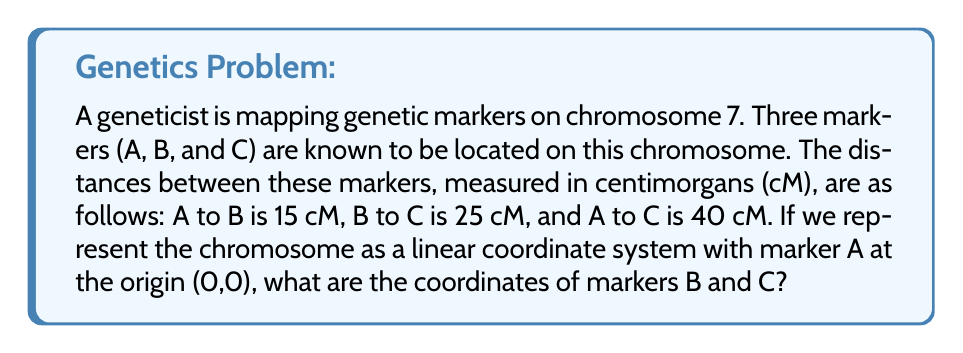Can you answer this question? To solve this problem, we need to follow these steps:

1) First, let's consider the chromosome as a one-dimensional coordinate system, with marker A at the origin (0,0).

2) The distance between markers is given in centimorgans (cM), which we can use as our unit of measurement on this coordinate system.

3) We know that:
   - A to B is 15 cM
   - B to C is 25 cM
   - A to C is 40 cM

4) Since A is at the origin (0,0), and the chromosome is linear, we can deduce that B and C will be on the positive x-axis.

5) For marker B:
   The distance from A to B is 15 cM, so B's coordinate is simply (15, 0).

6) For marker C:
   We have two pieces of information:
   - The distance from A to C is 40 cM
   - The distance from B to C is 25 cM

   Both of these should give us the same result for C's position.

   Using the distance from A: C's coordinate is (40, 0)
   
   Using the distance from B: 
   $$(15 + 25, 0) = (40, 0)$$

   This confirms our calculation.

Therefore, the coordinates of the markers are:
A: (0, 0)
B: (15, 0)
C: (40, 0)

This linear representation allows geneticists to visualize the relative positions of genetic markers on a chromosome, which is crucial for understanding gene linkage and mapping the genome.
Answer: Marker B: (15, 0)
Marker C: (40, 0) 